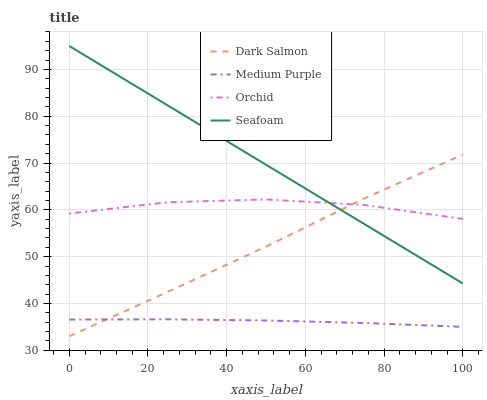Does Medium Purple have the minimum area under the curve?
Answer yes or no. Yes. Does Seafoam have the maximum area under the curve?
Answer yes or no. Yes. Does Dark Salmon have the minimum area under the curve?
Answer yes or no. No. Does Dark Salmon have the maximum area under the curve?
Answer yes or no. No. Is Seafoam the smoothest?
Answer yes or no. Yes. Is Orchid the roughest?
Answer yes or no. Yes. Is Dark Salmon the smoothest?
Answer yes or no. No. Is Dark Salmon the roughest?
Answer yes or no. No. Does Dark Salmon have the lowest value?
Answer yes or no. Yes. Does Seafoam have the lowest value?
Answer yes or no. No. Does Seafoam have the highest value?
Answer yes or no. Yes. Does Dark Salmon have the highest value?
Answer yes or no. No. Is Medium Purple less than Orchid?
Answer yes or no. Yes. Is Seafoam greater than Medium Purple?
Answer yes or no. Yes. Does Orchid intersect Seafoam?
Answer yes or no. Yes. Is Orchid less than Seafoam?
Answer yes or no. No. Is Orchid greater than Seafoam?
Answer yes or no. No. Does Medium Purple intersect Orchid?
Answer yes or no. No. 